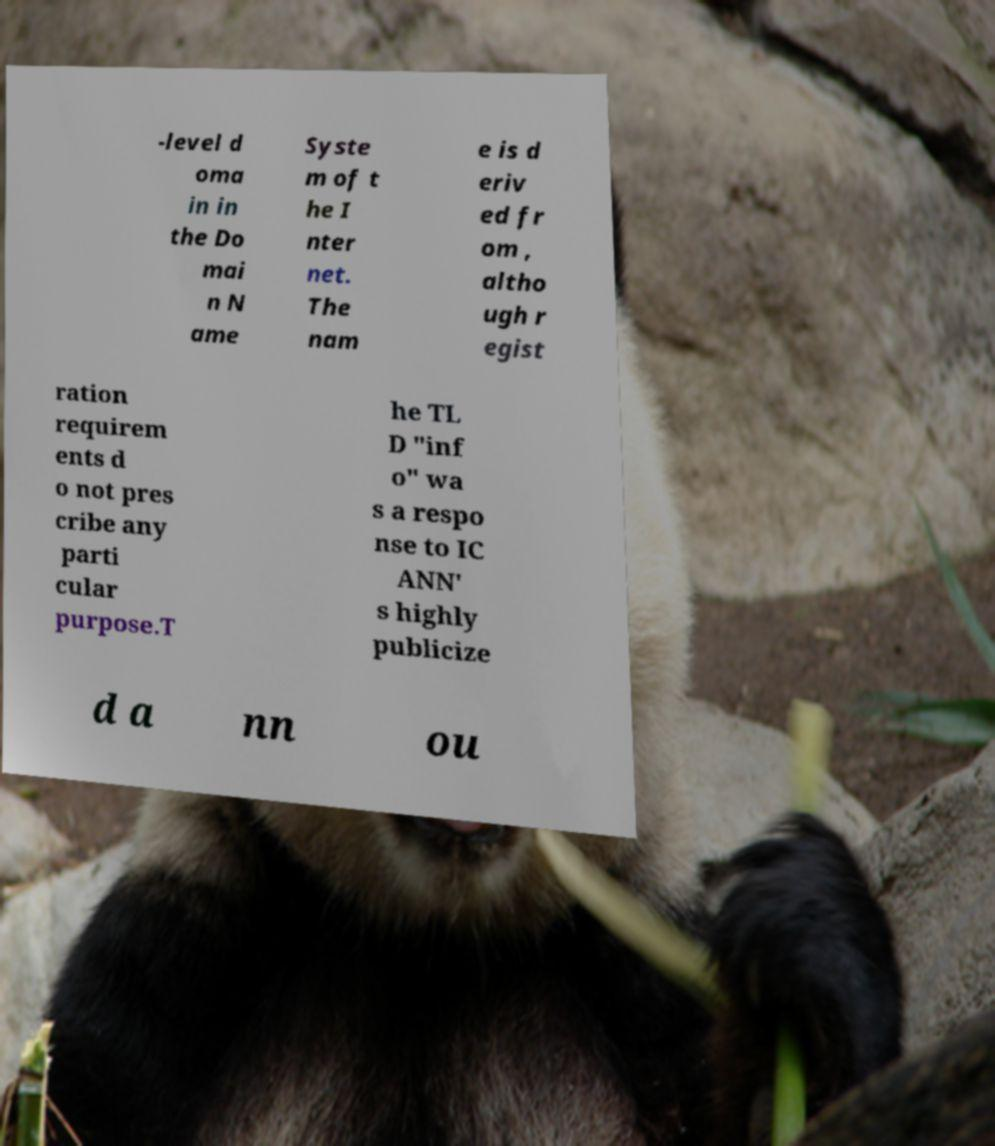I need the written content from this picture converted into text. Can you do that? -level d oma in in the Do mai n N ame Syste m of t he I nter net. The nam e is d eriv ed fr om , altho ugh r egist ration requirem ents d o not pres cribe any parti cular purpose.T he TL D "inf o" wa s a respo nse to IC ANN' s highly publicize d a nn ou 